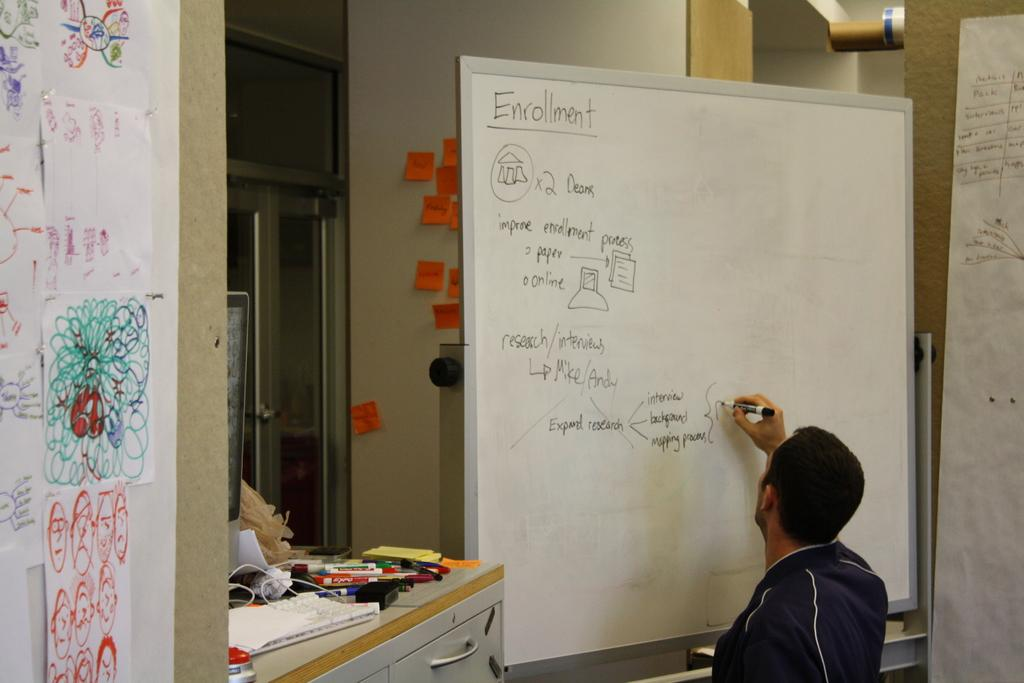<image>
Offer a succinct explanation of the picture presented. A man is writing on a whiteboard that says enrollment. 